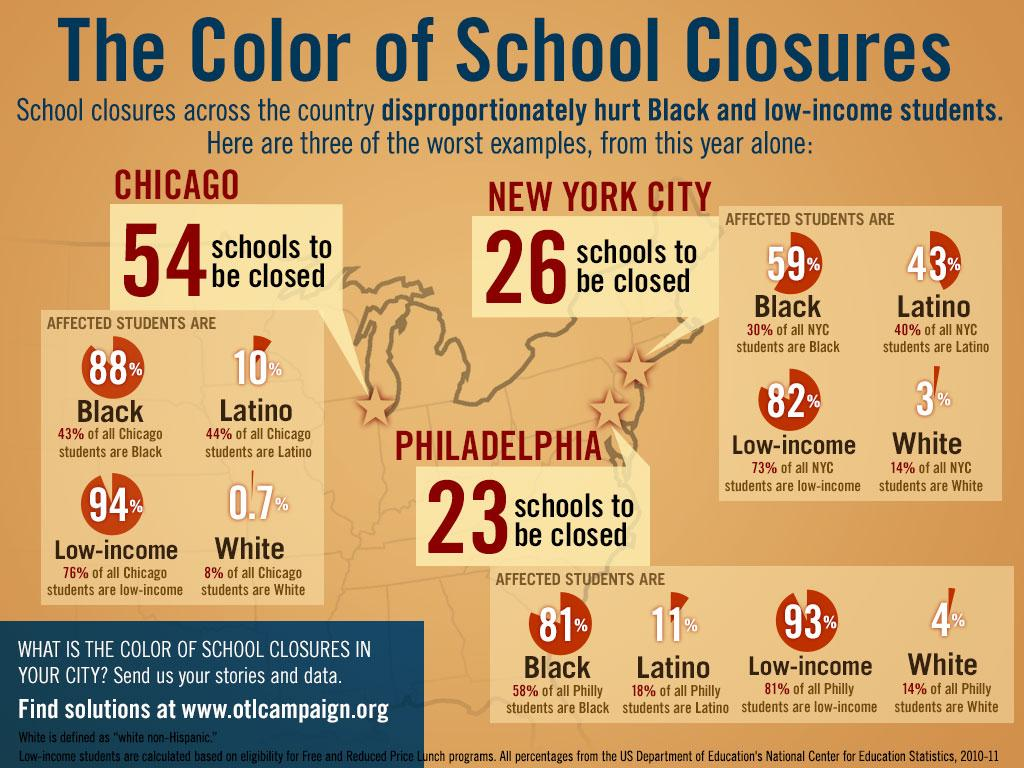Highlight a few significant elements in this photo. The closure of schools in Philadelphia would affect a significant percentage of Latino students, with 81%, 11%, or 93% of them potentially being impacted, according to the data provided. According to the data, the closure of schools in Chicago is expected to affect 94% of low-income students. The closure of schools in Philadelphia would have the least impact on the white community. Of the students in New York City, 44%, 73%, and 14% are white, with the lowest percentage being 14%. The percentage of black students among all students in Philadelphia is 58%. 